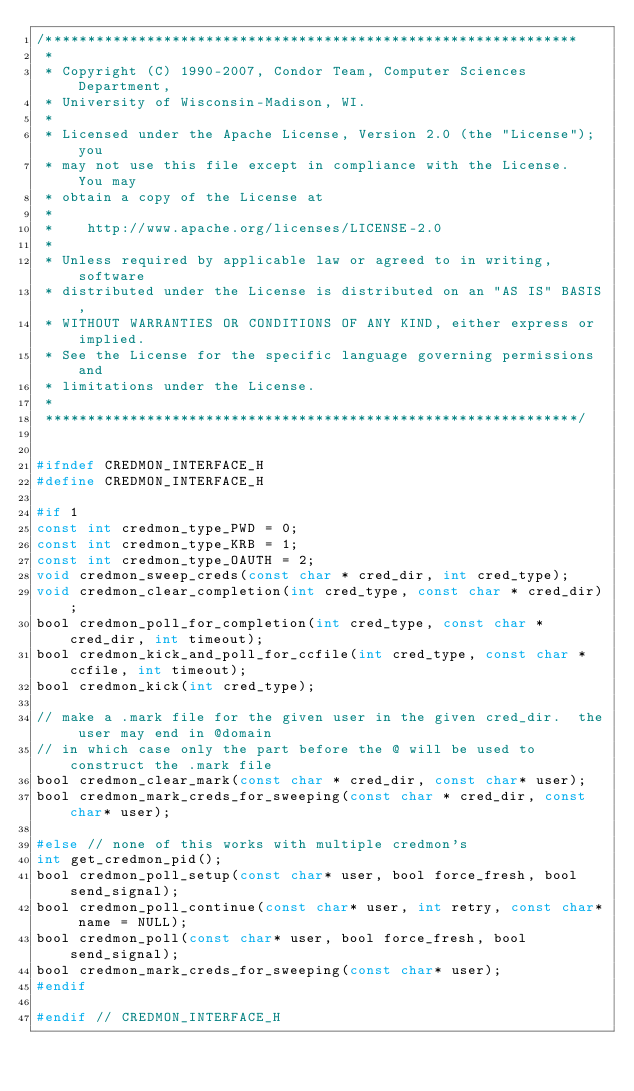<code> <loc_0><loc_0><loc_500><loc_500><_C_>/***************************************************************
 *
 * Copyright (C) 1990-2007, Condor Team, Computer Sciences Department,
 * University of Wisconsin-Madison, WI.
 * 
 * Licensed under the Apache License, Version 2.0 (the "License"); you
 * may not use this file except in compliance with the License.  You may
 * obtain a copy of the License at
 * 
 *    http://www.apache.org/licenses/LICENSE-2.0
 * 
 * Unless required by applicable law or agreed to in writing, software
 * distributed under the License is distributed on an "AS IS" BASIS,
 * WITHOUT WARRANTIES OR CONDITIONS OF ANY KIND, either express or implied.
 * See the License for the specific language governing permissions and
 * limitations under the License.
 *
 ***************************************************************/


#ifndef CREDMON_INTERFACE_H
#define CREDMON_INTERFACE_H

#if 1
const int credmon_type_PWD = 0;
const int credmon_type_KRB = 1;
const int credmon_type_OAUTH = 2;
void credmon_sweep_creds(const char * cred_dir, int cred_type);
void credmon_clear_completion(int cred_type, const char * cred_dir);
bool credmon_poll_for_completion(int cred_type, const char * cred_dir, int timeout);
bool credmon_kick_and_poll_for_ccfile(int cred_type, const char * ccfile, int timeout);
bool credmon_kick(int cred_type);

// make a .mark file for the given user in the given cred_dir.  the user may end in @domain
// in which case only the part before the @ will be used to construct the .mark file
bool credmon_clear_mark(const char * cred_dir, const char* user);
bool credmon_mark_creds_for_sweeping(const char * cred_dir, const char* user);

#else // none of this works with multiple credmon's
int get_credmon_pid();
bool credmon_poll_setup(const char* user, bool force_fresh, bool send_signal);
bool credmon_poll_continue(const char* user, int retry, const char* name = NULL);
bool credmon_poll(const char* user, bool force_fresh, bool send_signal);
bool credmon_mark_creds_for_sweeping(const char* user);
#endif

#endif // CREDMON_INTERFACE_H

</code> 